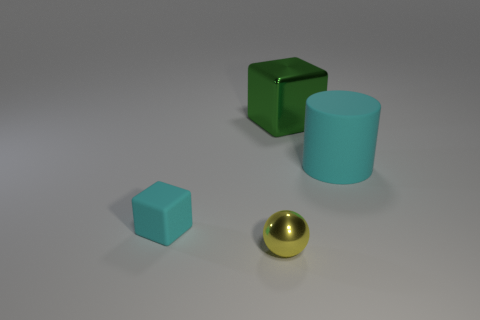Can you tell me what these objects are used for? While this image shows basic geometric shapes, their specific use isn't evident. In a real-world context, such shapes might be used as teaching aids for educational purposes, to introduce concepts of geometry and spatial understanding. 